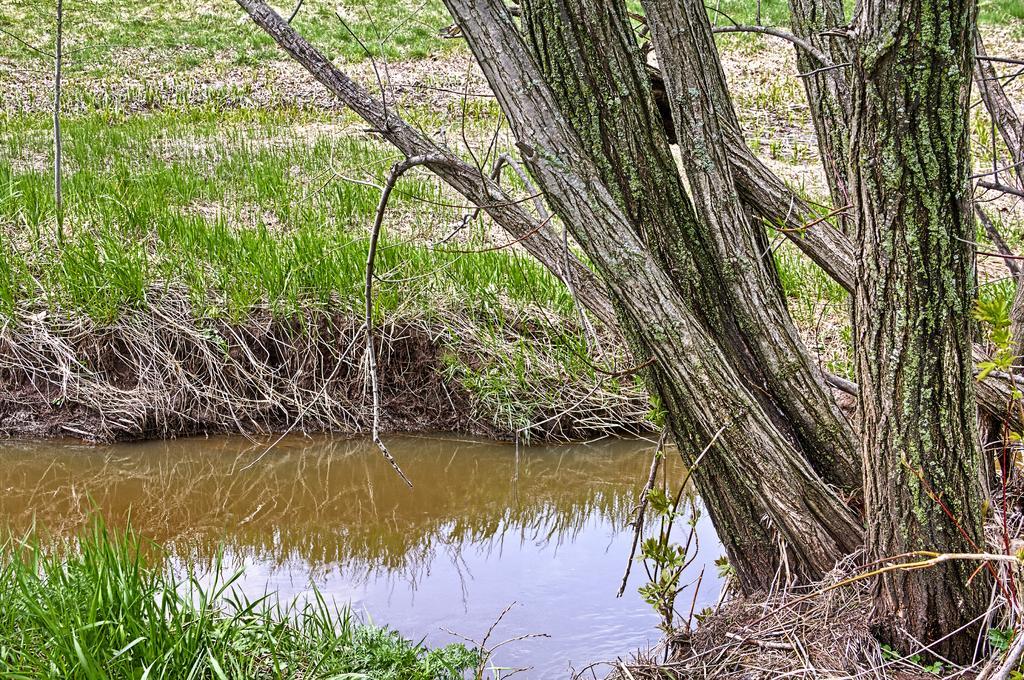Please provide a concise description of this image. In this picture I can see water, grass and tree trunks. 